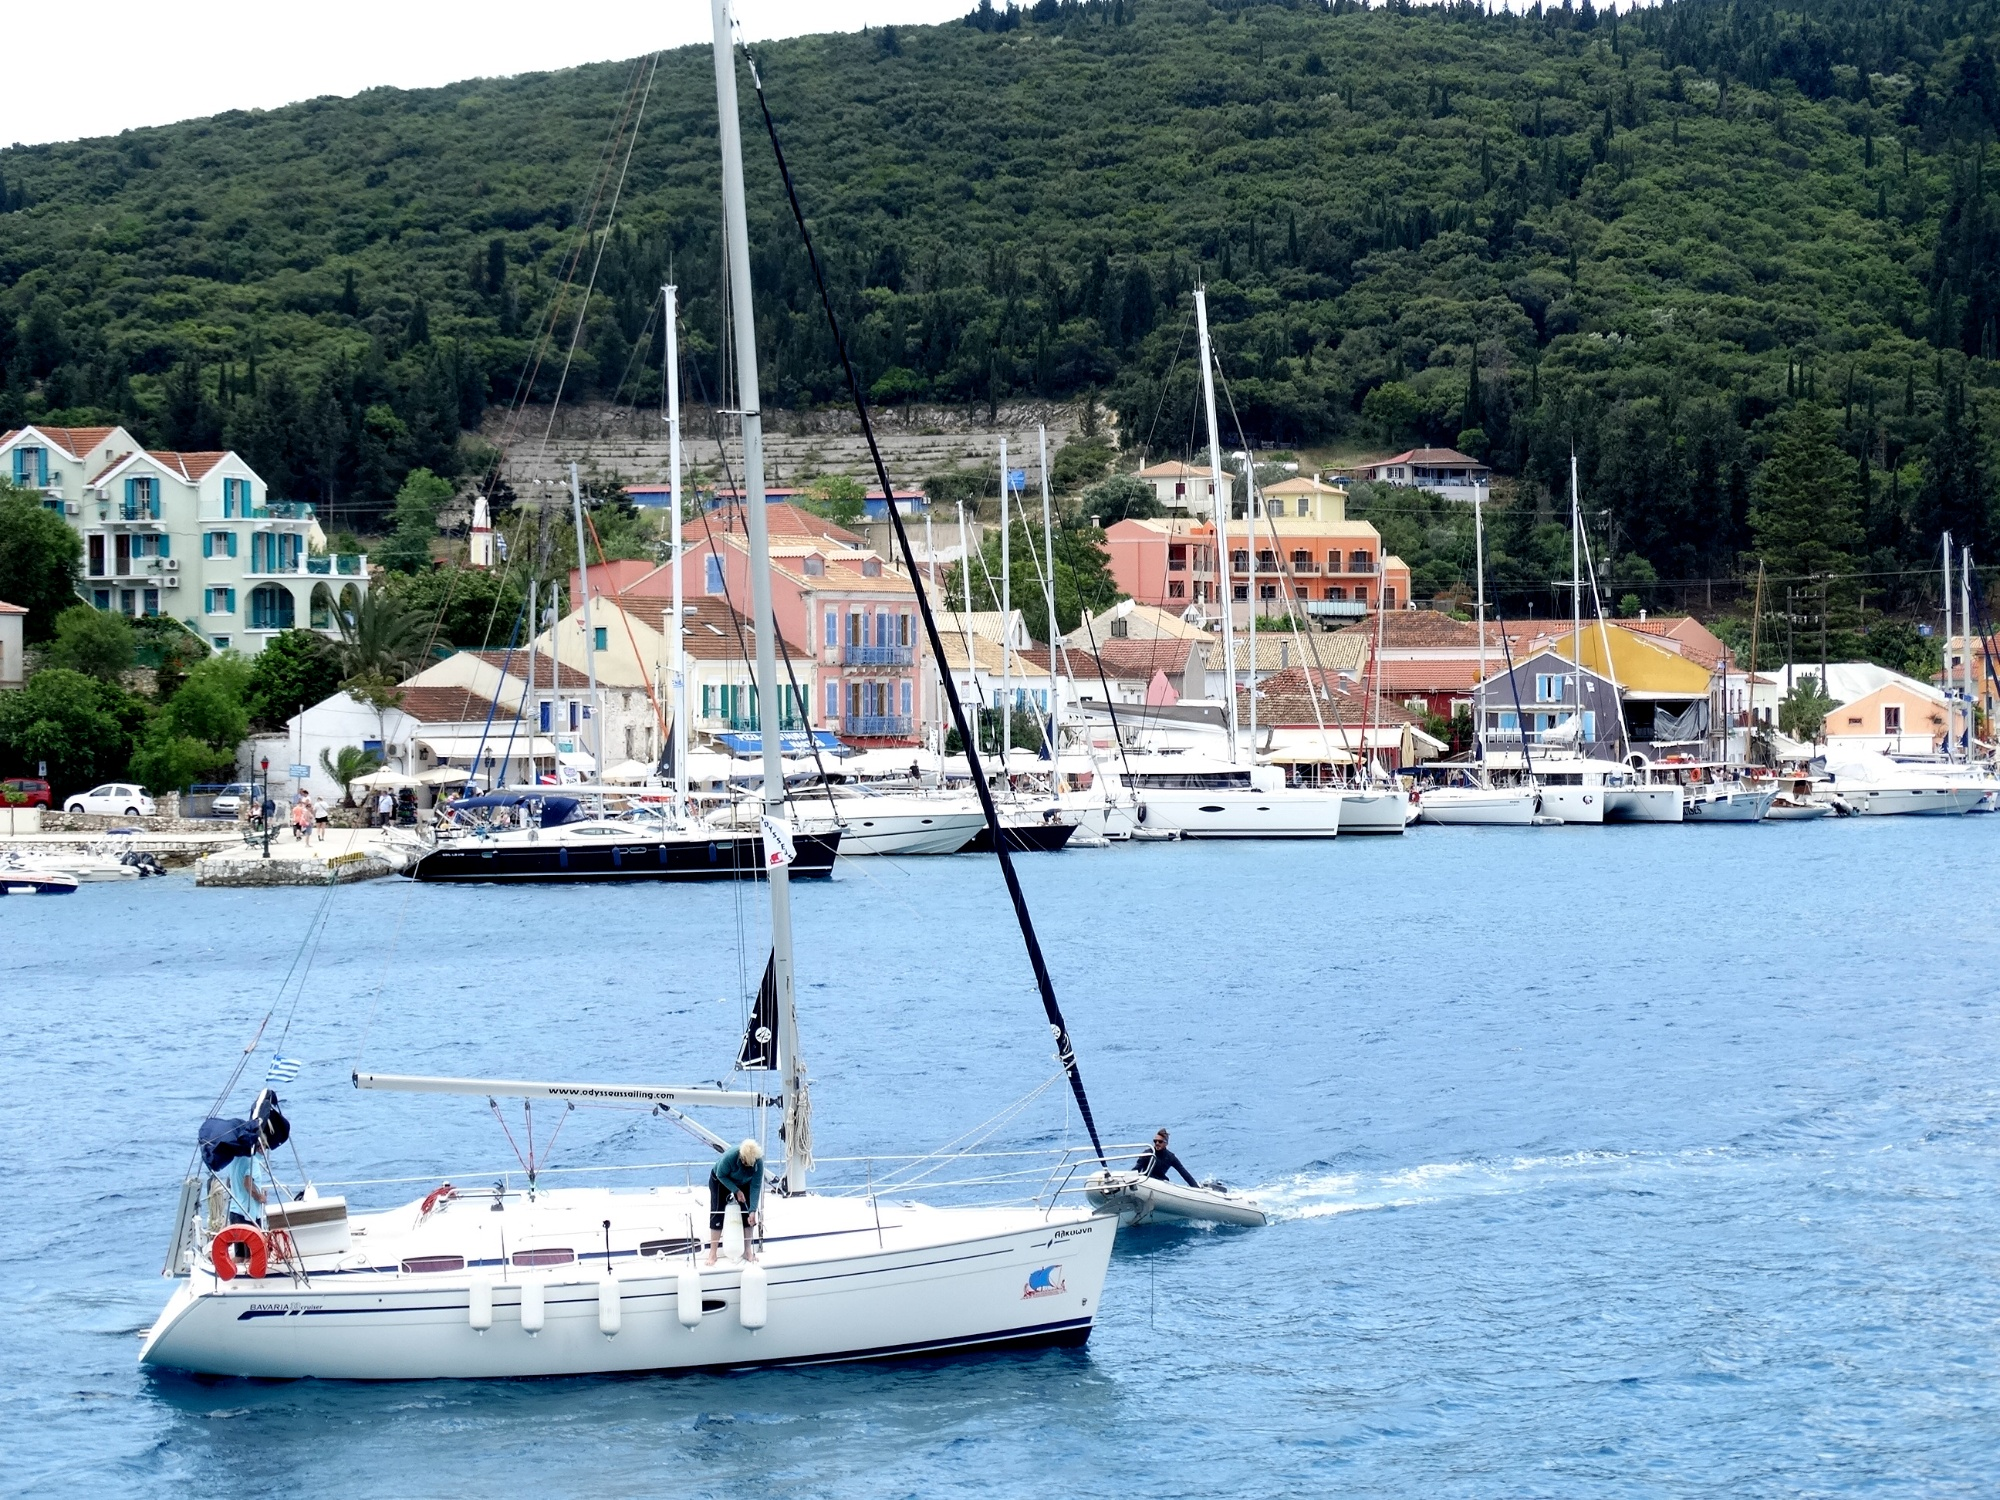Could you tell me more about the architecture of the buildings in this image? Certainly! The architecture reflects a blend of traditional Mediterranean elements: colorful facades, terracotta roof tiles, balconies, and possibly shutters to shield against the sun. The buildings are constructed in close proximity, typical of a dense coastal town, where space is at a premium. Variations in building heights and colors add character to the townscape, while the architecture seems to integrate harmoniously with the natural topography, ascending the slope of the hill. 